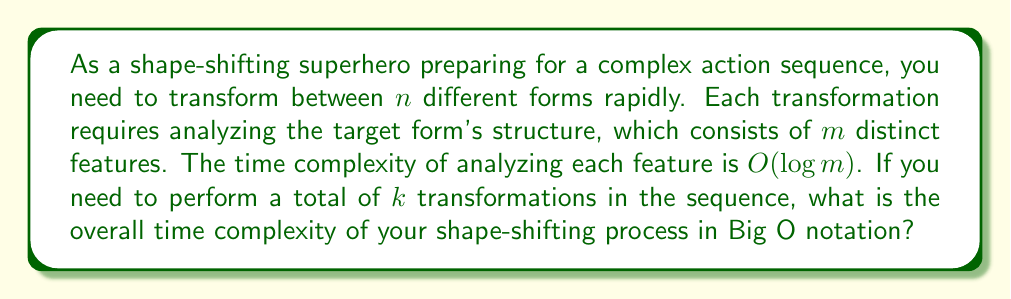Provide a solution to this math problem. Let's break down the problem step-by-step:

1) For each transformation:
   - You need to analyze $m$ features
   - Each feature analysis takes $O(\log m)$ time

2) The time complexity for one transformation:
   $$T_{single} = m \cdot O(\log m) = O(m \log m)$$

3) You need to perform $k$ transformations in total.
   The total time complexity:
   $$T_{total} = k \cdot O(m \log m) = O(k m \log m)$$

4) However, we need to consider that you have $n$ different forms.
   This doesn't directly affect the time complexity of the transformations,
   but it's worth noting that $k \leq n^2$ in the worst case (transforming from each form to every other form).

5) Therefore, we can express the worst-case time complexity in terms of $n$ and $m$:
   $$T_{worst} = O(n^2 m \log m)$$

However, since the question asks for the complexity in terms of $k$, $n$, and $m$,
we'll stick with the expression $O(k m \log m)$.
Answer: $O(k m \log m)$ 